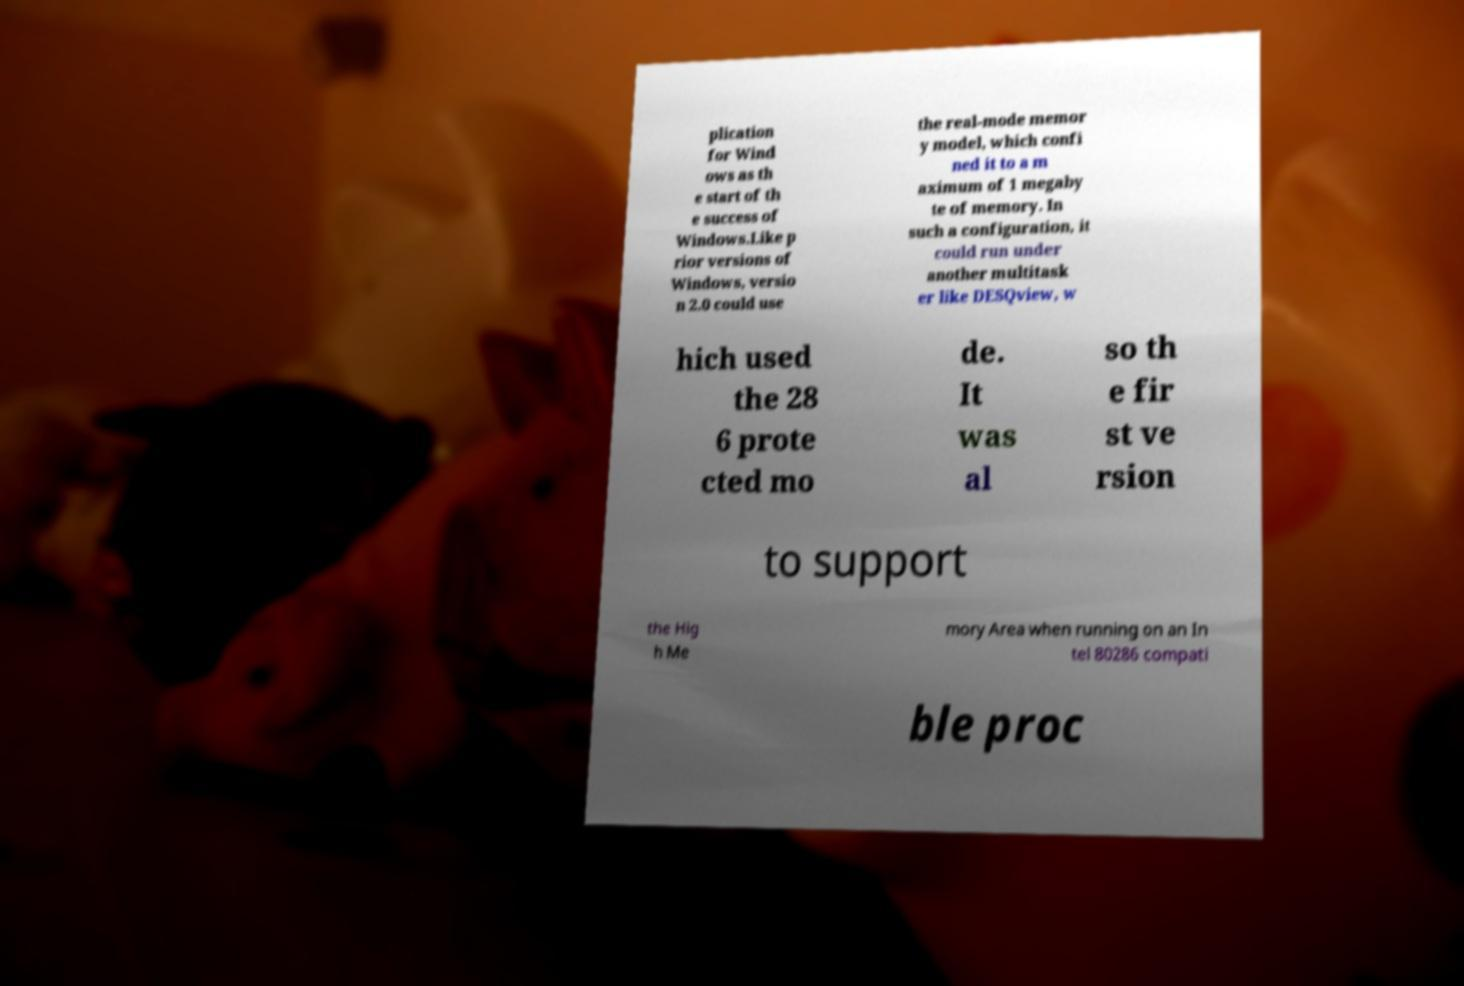Could you assist in decoding the text presented in this image and type it out clearly? plication for Wind ows as th e start of th e success of Windows.Like p rior versions of Windows, versio n 2.0 could use the real-mode memor y model, which confi ned it to a m aximum of 1 megaby te of memory. In such a configuration, it could run under another multitask er like DESQview, w hich used the 28 6 prote cted mo de. It was al so th e fir st ve rsion to support the Hig h Me mory Area when running on an In tel 80286 compati ble proc 